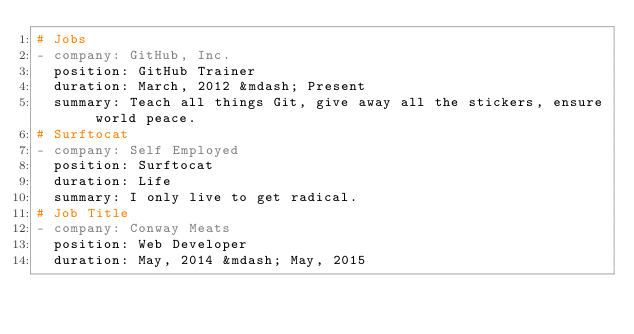Convert code to text. <code><loc_0><loc_0><loc_500><loc_500><_YAML_># Jobs
- company: GitHub, Inc.
  position: GitHub Trainer
  duration: March, 2012 &mdash; Present
  summary: Teach all things Git, give away all the stickers, ensure world peace.
# Surftocat
- company: Self Employed
  position: Surftocat
  duration: Life
  summary: I only live to get radical.
# Job Title
- company: Conway Meats
  position: Web Developer
  duration: May, 2014 &mdash; May, 2015</code> 